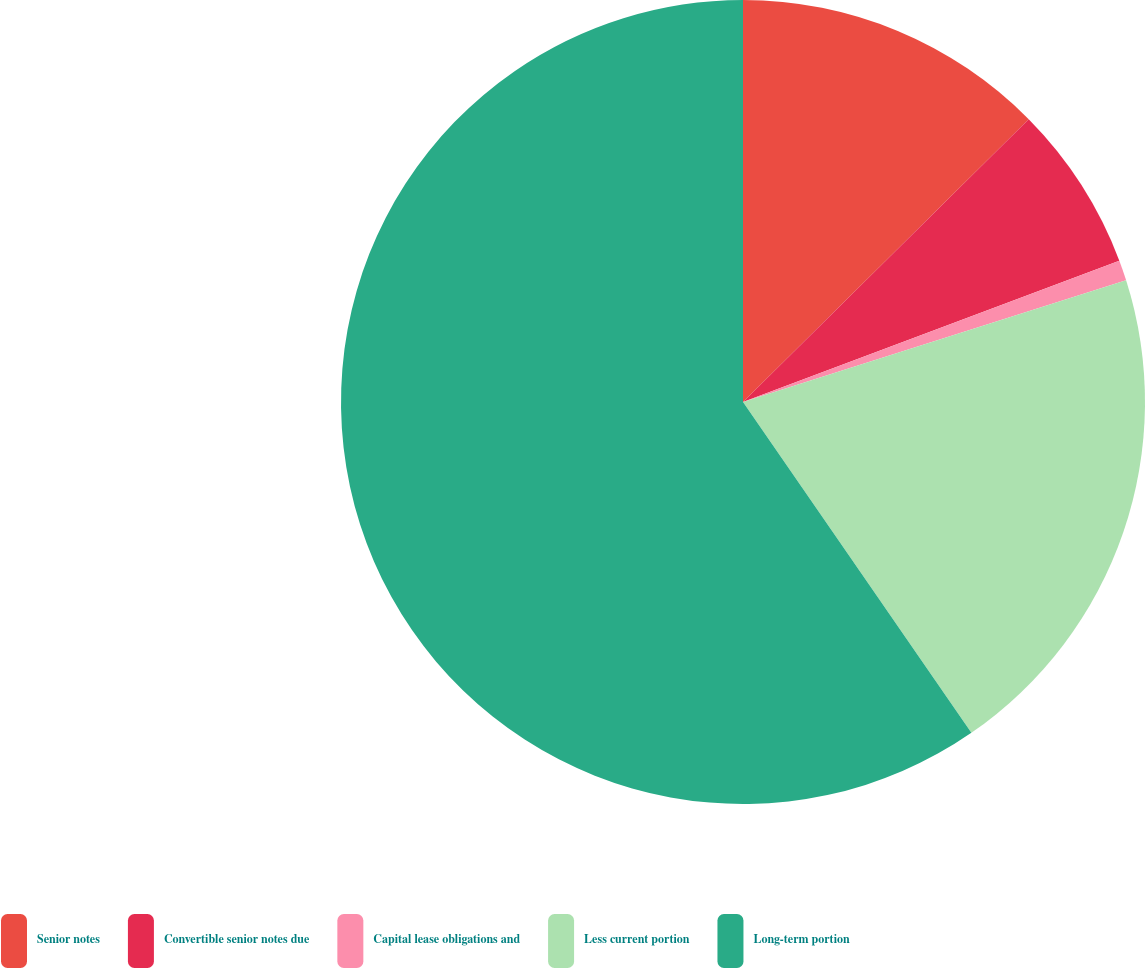Convert chart. <chart><loc_0><loc_0><loc_500><loc_500><pie_chart><fcel>Senior notes<fcel>Convertible senior notes due<fcel>Capital lease obligations and<fcel>Less current portion<fcel>Long-term portion<nl><fcel>12.58%<fcel>6.7%<fcel>0.82%<fcel>20.28%<fcel>59.61%<nl></chart> 